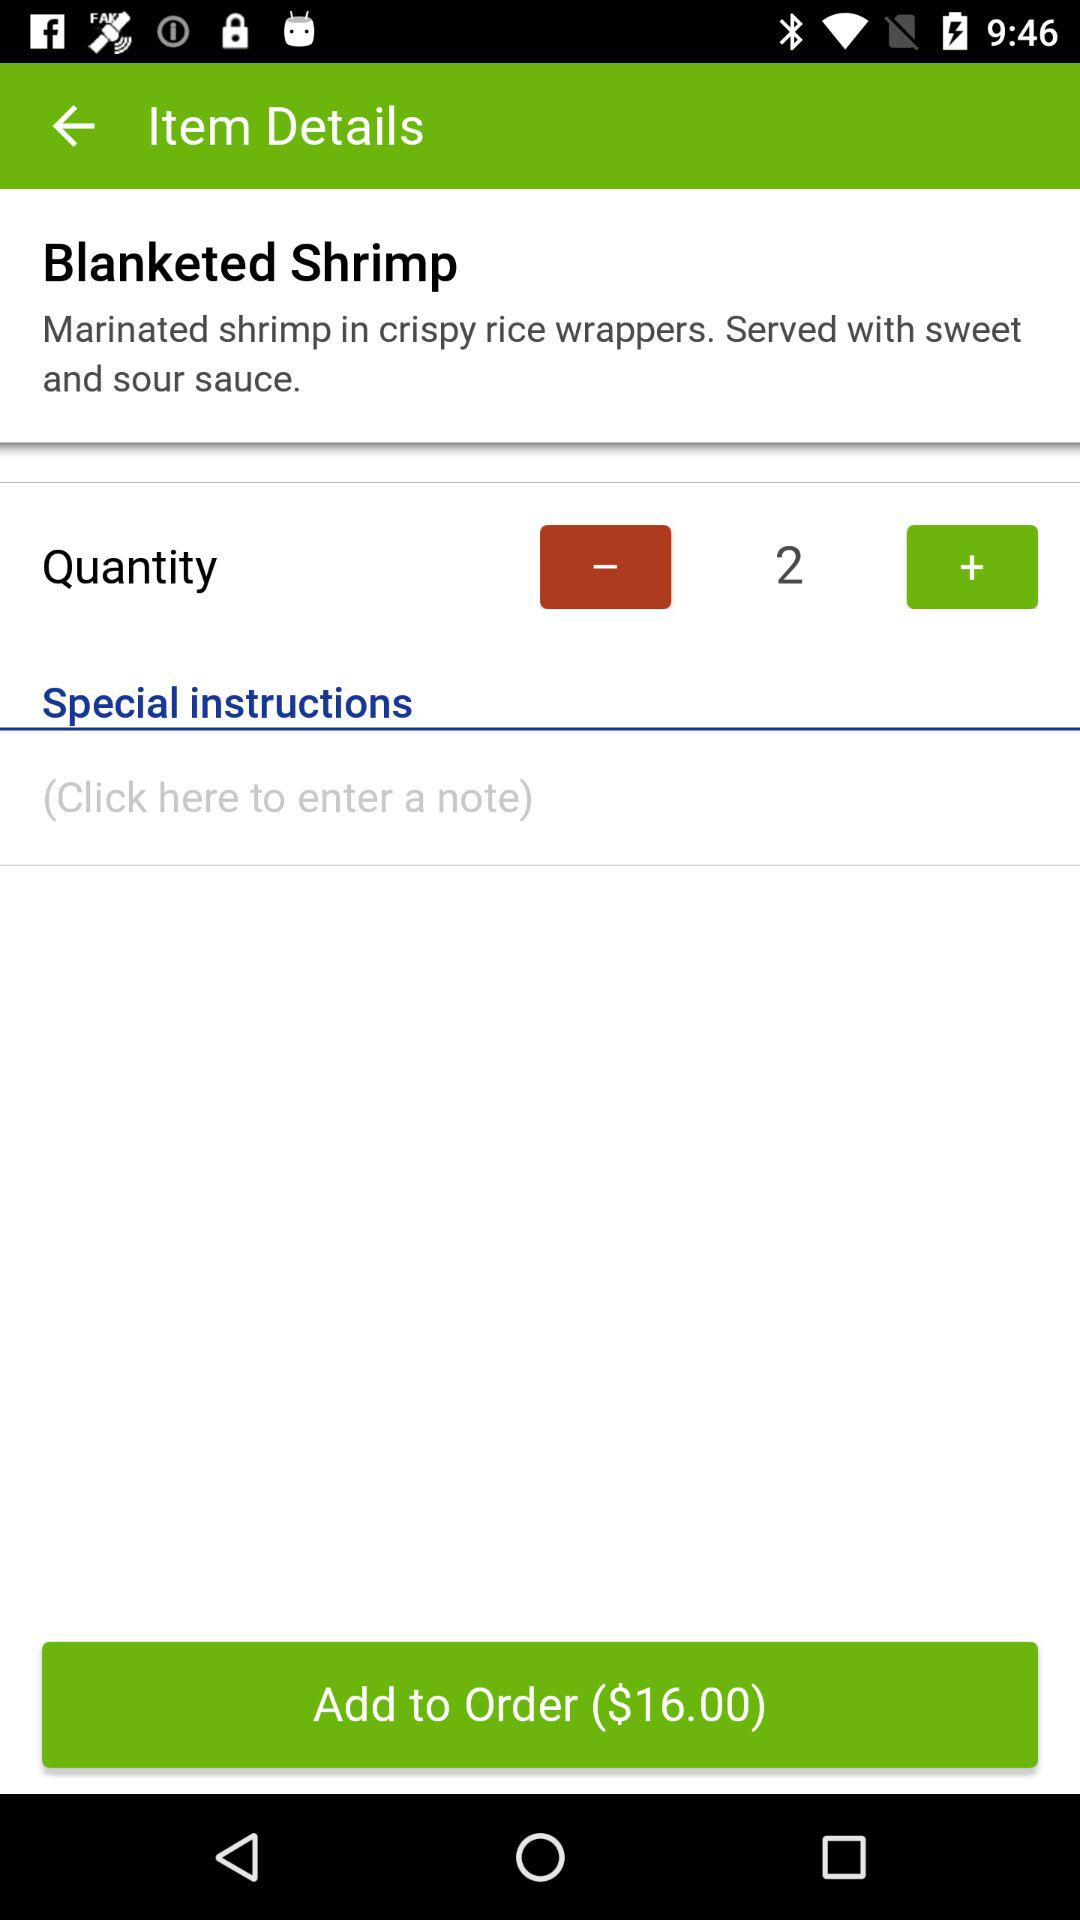What is the price of the order? The price of the order is $16.00. 